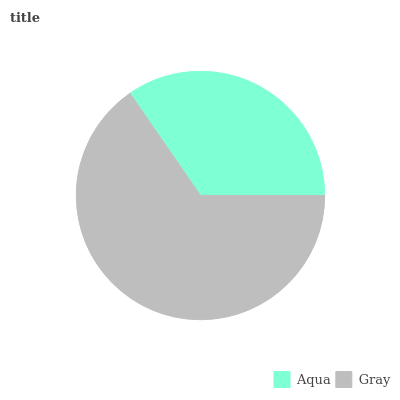Is Aqua the minimum?
Answer yes or no. Yes. Is Gray the maximum?
Answer yes or no. Yes. Is Gray the minimum?
Answer yes or no. No. Is Gray greater than Aqua?
Answer yes or no. Yes. Is Aqua less than Gray?
Answer yes or no. Yes. Is Aqua greater than Gray?
Answer yes or no. No. Is Gray less than Aqua?
Answer yes or no. No. Is Gray the high median?
Answer yes or no. Yes. Is Aqua the low median?
Answer yes or no. Yes. Is Aqua the high median?
Answer yes or no. No. Is Gray the low median?
Answer yes or no. No. 